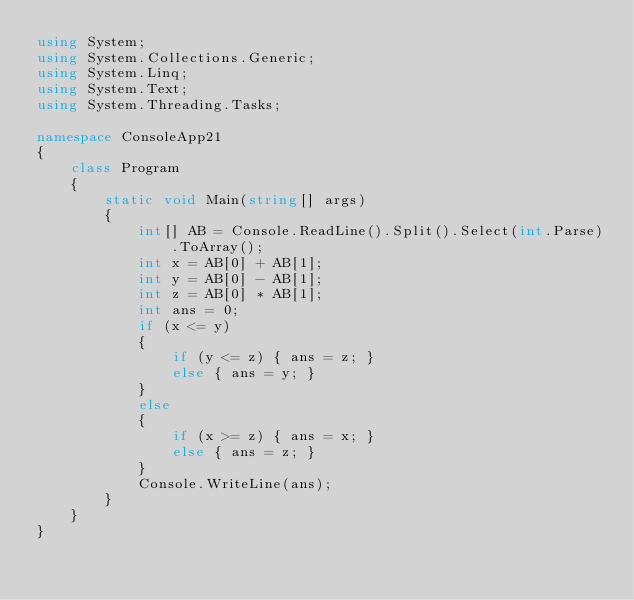<code> <loc_0><loc_0><loc_500><loc_500><_C#_>using System;
using System.Collections.Generic;
using System.Linq;
using System.Text;
using System.Threading.Tasks;

namespace ConsoleApp21
{
    class Program
    {
        static void Main(string[] args)
        {
            int[] AB = Console.ReadLine().Split().Select(int.Parse).ToArray();
            int x = AB[0] + AB[1];
            int y = AB[0] - AB[1];
            int z = AB[0] * AB[1];
            int ans = 0;
            if (x <= y)
            {
                if (y <= z) { ans = z; }
                else { ans = y; }
            }
            else
            {
                if (x >= z) { ans = x; }
                else { ans = z; }
            }
            Console.WriteLine(ans);
        }
    }
}</code> 